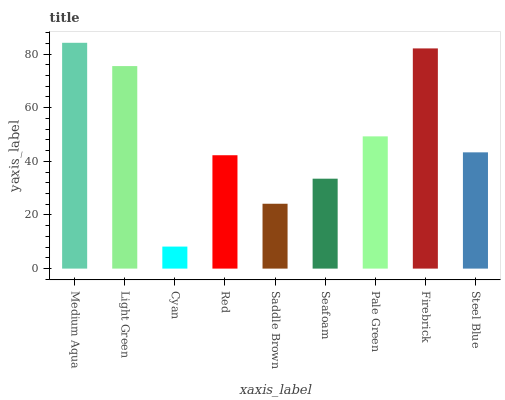Is Cyan the minimum?
Answer yes or no. Yes. Is Medium Aqua the maximum?
Answer yes or no. Yes. Is Light Green the minimum?
Answer yes or no. No. Is Light Green the maximum?
Answer yes or no. No. Is Medium Aqua greater than Light Green?
Answer yes or no. Yes. Is Light Green less than Medium Aqua?
Answer yes or no. Yes. Is Light Green greater than Medium Aqua?
Answer yes or no. No. Is Medium Aqua less than Light Green?
Answer yes or no. No. Is Steel Blue the high median?
Answer yes or no. Yes. Is Steel Blue the low median?
Answer yes or no. Yes. Is Red the high median?
Answer yes or no. No. Is Red the low median?
Answer yes or no. No. 